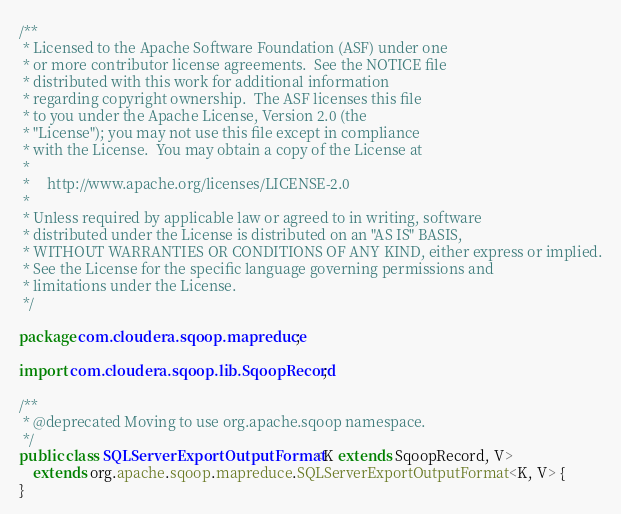Convert code to text. <code><loc_0><loc_0><loc_500><loc_500><_Java_>/**
 * Licensed to the Apache Software Foundation (ASF) under one
 * or more contributor license agreements.  See the NOTICE file
 * distributed with this work for additional information
 * regarding copyright ownership.  The ASF licenses this file
 * to you under the Apache License, Version 2.0 (the
 * "License"); you may not use this file except in compliance
 * with the License.  You may obtain a copy of the License at
 *
 *     http://www.apache.org/licenses/LICENSE-2.0
 *
 * Unless required by applicable law or agreed to in writing, software
 * distributed under the License is distributed on an "AS IS" BASIS,
 * WITHOUT WARRANTIES OR CONDITIONS OF ANY KIND, either express or implied.
 * See the License for the specific language governing permissions and
 * limitations under the License.
 */

package com.cloudera.sqoop.mapreduce;

import com.cloudera.sqoop.lib.SqoopRecord;

/**
 * @deprecated Moving to use org.apache.sqoop namespace.
 */
public class SQLServerExportOutputFormat<K extends SqoopRecord, V>
    extends org.apache.sqoop.mapreduce.SQLServerExportOutputFormat<K, V> {
}
</code> 